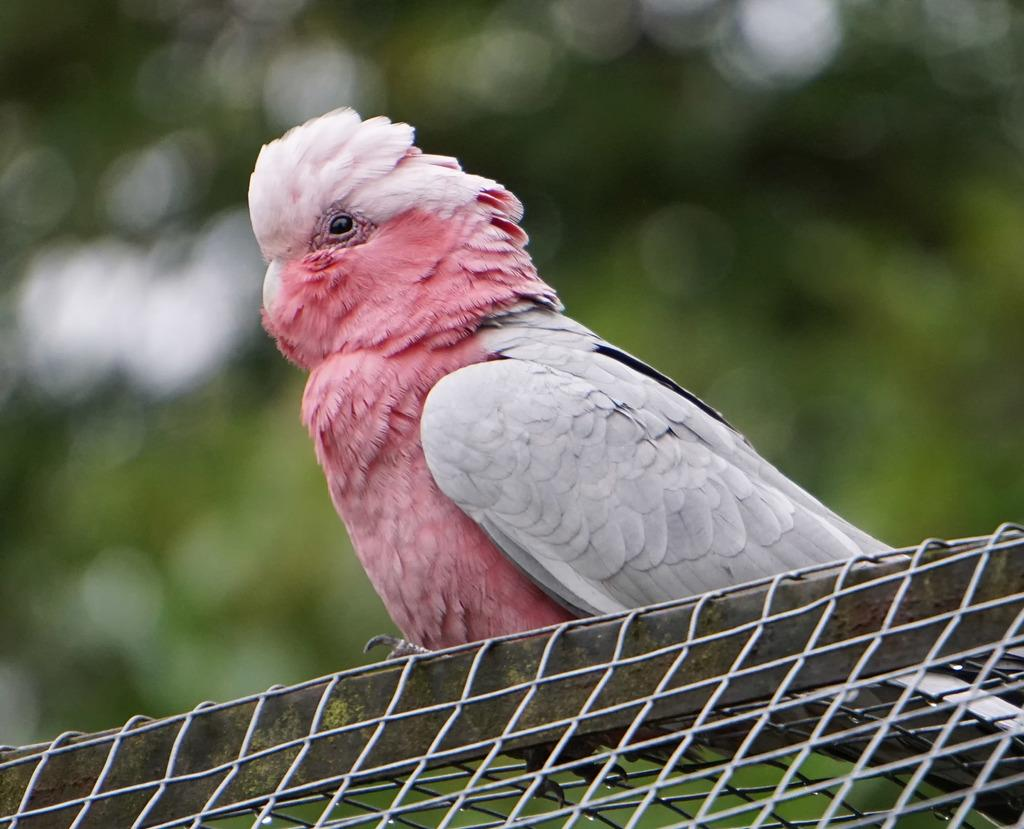What is the main focus of the image? The main focus of the image is a bird. Can you describe the background of the image? The background of the image is blurred. What is present at the bottom portion of the image? There is a mesh at the bottom portion of the image. How many pizzas are being delivered by the car in the image? There is no car or pizzas present in the image. 